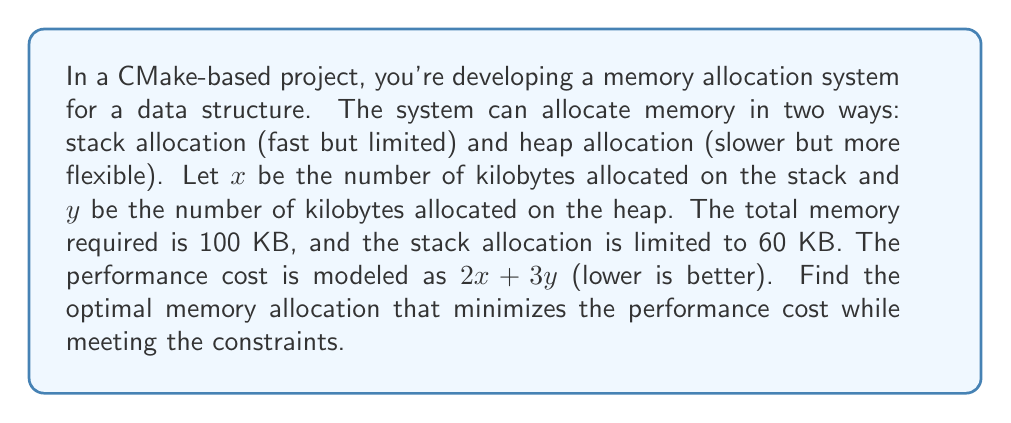Could you help me with this problem? To solve this problem, we'll use linear programming techniques:

1. Define the objective function:
   Minimize $z = 2x + 3y$

2. List the constraints:
   $x + y = 100$ (total memory requirement)
   $x \leq 60$ (stack allocation limit)
   $x \geq 0, y \geq 0$ (non-negative allocations)

3. Graph the feasible region:
   The constraints form a triangle bounded by the lines:
   $y = 100 - x$
   $x = 60$
   $x = 0$
   $y = 0$

4. Find the vertices of the feasible region:
   (0, 100), (60, 40), (60, 0)

5. Evaluate the objective function at each vertex:
   (0, 100): $z = 2(0) + 3(100) = 300$
   (60, 40): $z = 2(60) + 3(40) = 240$
   (60, 0): $z = 2(60) + 3(0) = 120$

6. The minimum value occurs at (60, 40), which represents:
   60 KB allocated on the stack
   40 KB allocated on the heap

This allocation minimizes the performance cost while meeting all constraints.
Answer: (60, 40) 